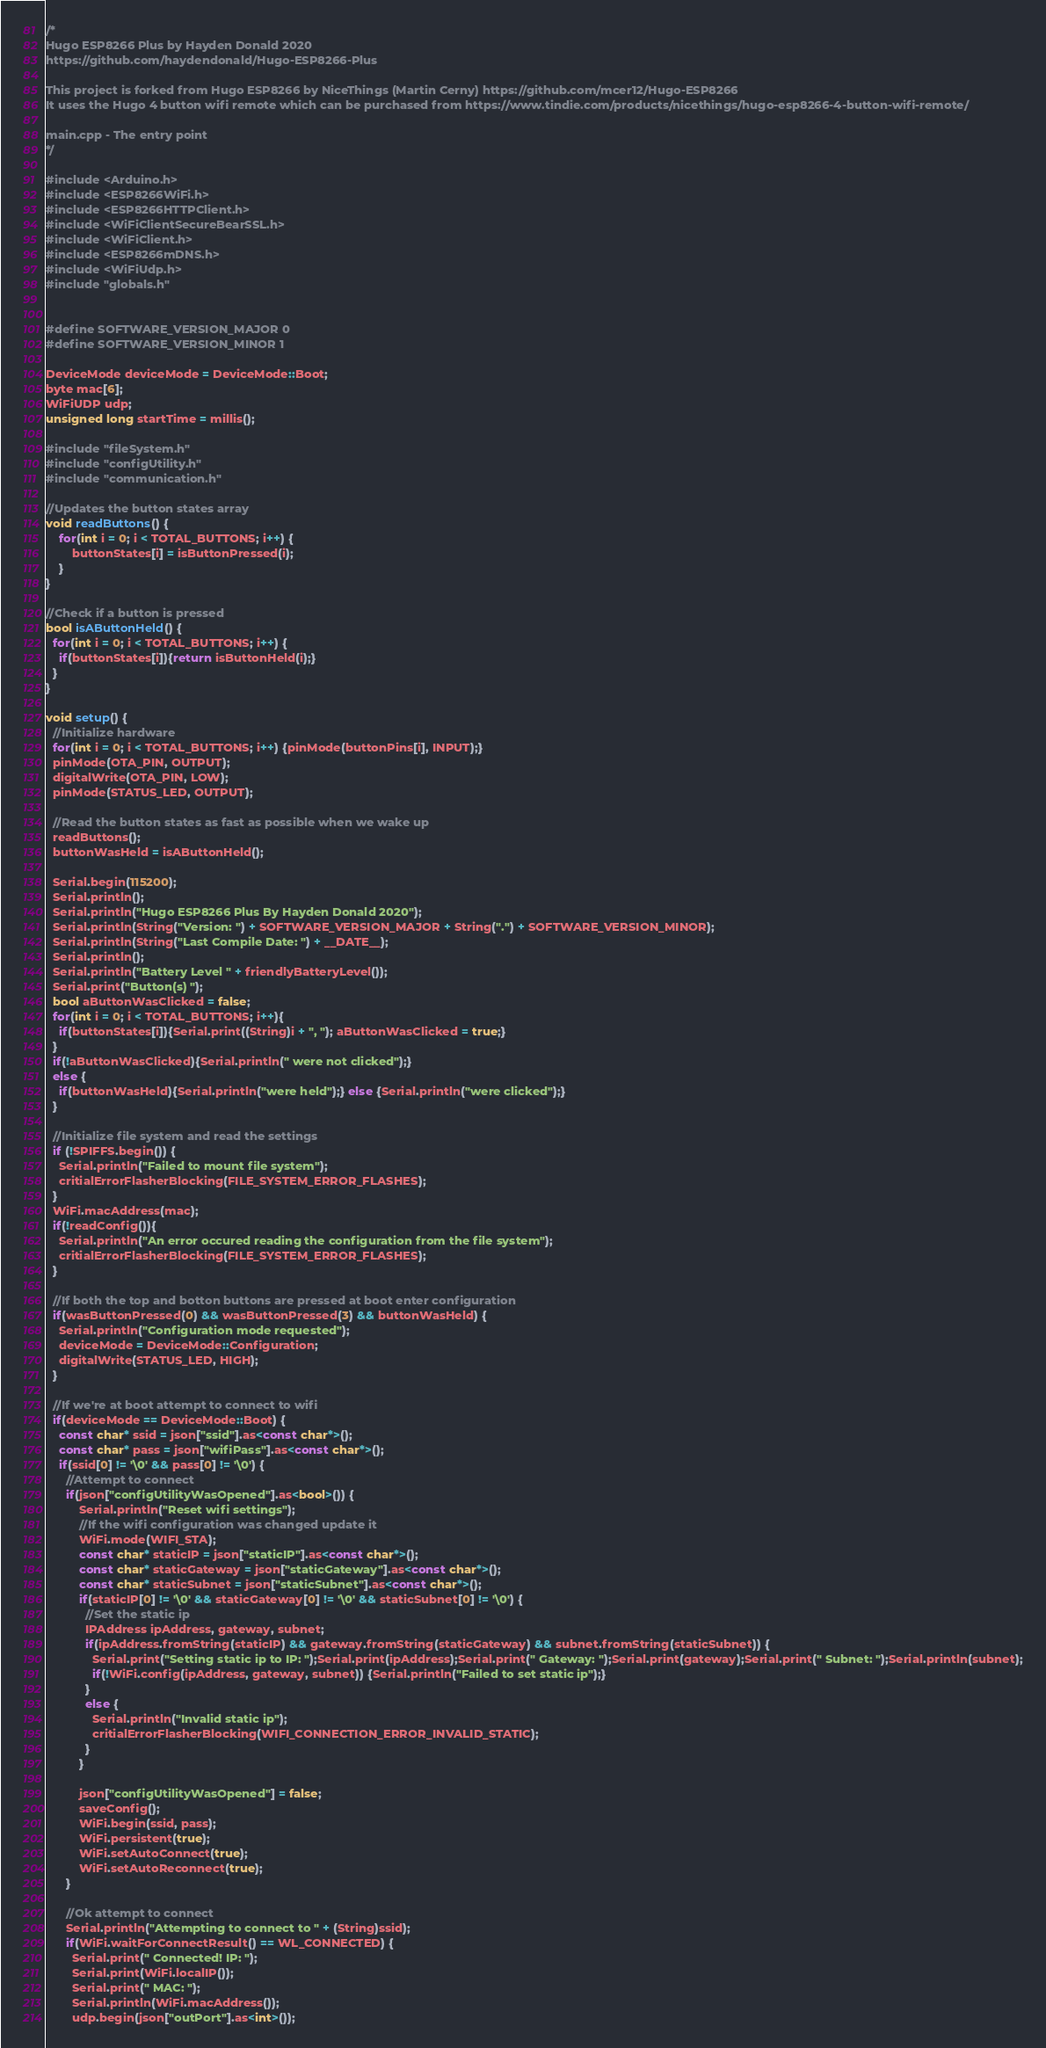Convert code to text. <code><loc_0><loc_0><loc_500><loc_500><_C++_>/*
Hugo ESP8266 Plus by Hayden Donald 2020
https://github.com/haydendonald/Hugo-ESP8266-Plus

This project is forked from Hugo ESP8266 by NiceThings (Martin Cerny) https://github.com/mcer12/Hugo-ESP8266
It uses the Hugo 4 button wifi remote which can be purchased from https://www.tindie.com/products/nicethings/hugo-esp8266-4-button-wifi-remote/

main.cpp - The entry point
*/

#include <Arduino.h>
#include <ESP8266WiFi.h>
#include <ESP8266HTTPClient.h>
#include <WiFiClientSecureBearSSL.h>
#include <WiFiClient.h>
#include <ESP8266mDNS.h>
#include <WiFiUdp.h>
#include "globals.h"


#define SOFTWARE_VERSION_MAJOR 0
#define SOFTWARE_VERSION_MINOR 1

DeviceMode deviceMode = DeviceMode::Boot;
byte mac[6];
WiFiUDP udp;
unsigned long startTime = millis();

#include "fileSystem.h"
#include "configUtility.h"
#include "communication.h"

//Updates the button states array
void readButtons() {
    for(int i = 0; i < TOTAL_BUTTONS; i++) {
        buttonStates[i] = isButtonPressed(i);
    }
}

//Check if a button is pressed
bool isAButtonHeld() {
  for(int i = 0; i < TOTAL_BUTTONS; i++) {
    if(buttonStates[i]){return isButtonHeld(i);}
  }
}

void setup() {
  //Initialize hardware
  for(int i = 0; i < TOTAL_BUTTONS; i++) {pinMode(buttonPins[i], INPUT);}
  pinMode(OTA_PIN, OUTPUT);
  digitalWrite(OTA_PIN, LOW);
  pinMode(STATUS_LED, OUTPUT);

  //Read the button states as fast as possible when we wake up
  readButtons();
  buttonWasHeld = isAButtonHeld();

  Serial.begin(115200);
  Serial.println();
  Serial.println("Hugo ESP8266 Plus By Hayden Donald 2020");
  Serial.println(String("Version: ") + SOFTWARE_VERSION_MAJOR + String(".") + SOFTWARE_VERSION_MINOR);
  Serial.println(String("Last Compile Date: ") + __DATE__);
  Serial.println();
  Serial.println("Battery Level " + friendlyBatteryLevel());
  Serial.print("Button(s) ");
  bool aButtonWasClicked = false;
  for(int i = 0; i < TOTAL_BUTTONS; i++){
    if(buttonStates[i]){Serial.print((String)i + ", "); aButtonWasClicked = true;}
  }
  if(!aButtonWasClicked){Serial.println(" were not clicked");}
  else {
    if(buttonWasHeld){Serial.println("were held");} else {Serial.println("were clicked");}
  }

  //Initialize file system and read the settings
  if (!SPIFFS.begin()) {
    Serial.println("Failed to mount file system");
    critialErrorFlasherBlocking(FILE_SYSTEM_ERROR_FLASHES);
  }
  WiFi.macAddress(mac);
  if(!readConfig()){
    Serial.println("An error occured reading the configuration from the file system");
    critialErrorFlasherBlocking(FILE_SYSTEM_ERROR_FLASHES);
  }

  //If both the top and botton buttons are pressed at boot enter configuration
  if(wasButtonPressed(0) && wasButtonPressed(3) && buttonWasHeld) {
    Serial.println("Configuration mode requested");
    deviceMode = DeviceMode::Configuration;
    digitalWrite(STATUS_LED, HIGH);
  }

  //If we're at boot attempt to connect to wifi
  if(deviceMode == DeviceMode::Boot) {
    const char* ssid = json["ssid"].as<const char*>();
    const char* pass = json["wifiPass"].as<const char*>();
    if(ssid[0] != '\0' && pass[0] != '\0') {
      //Attempt to connect
      if(json["configUtilityWasOpened"].as<bool>()) {
          Serial.println("Reset wifi settings");
          //If the wifi configuration was changed update it
          WiFi.mode(WIFI_STA);
          const char* staticIP = json["staticIP"].as<const char*>();
          const char* staticGateway = json["staticGateway"].as<const char*>();
          const char* staticSubnet = json["staticSubnet"].as<const char*>();
          if(staticIP[0] != '\0' && staticGateway[0] != '\0' && staticSubnet[0] != '\0') {
            //Set the static ip
            IPAddress ipAddress, gateway, subnet;
            if(ipAddress.fromString(staticIP) && gateway.fromString(staticGateway) && subnet.fromString(staticSubnet)) {
              Serial.print("Setting static ip to IP: ");Serial.print(ipAddress);Serial.print(" Gateway: ");Serial.print(gateway);Serial.print(" Subnet: ");Serial.println(subnet);
              if(!WiFi.config(ipAddress, gateway, subnet)) {Serial.println("Failed to set static ip");}
            }
            else {
              Serial.println("Invalid static ip");
              critialErrorFlasherBlocking(WIFI_CONNECTION_ERROR_INVALID_STATIC);
            }
          }

          json["configUtilityWasOpened"] = false;
          saveConfig();
          WiFi.begin(ssid, pass);
          WiFi.persistent(true);
          WiFi.setAutoConnect(true);
          WiFi.setAutoReconnect(true);
      }

      //Ok attempt to connect
      Serial.println("Attempting to connect to " + (String)ssid);
      if(WiFi.waitForConnectResult() == WL_CONNECTED) {
        Serial.print(" Connected! IP: ");
        Serial.print(WiFi.localIP());
        Serial.print(" MAC: ");
        Serial.println(WiFi.macAddress());
        udp.begin(json["outPort"].as<int>());</code> 